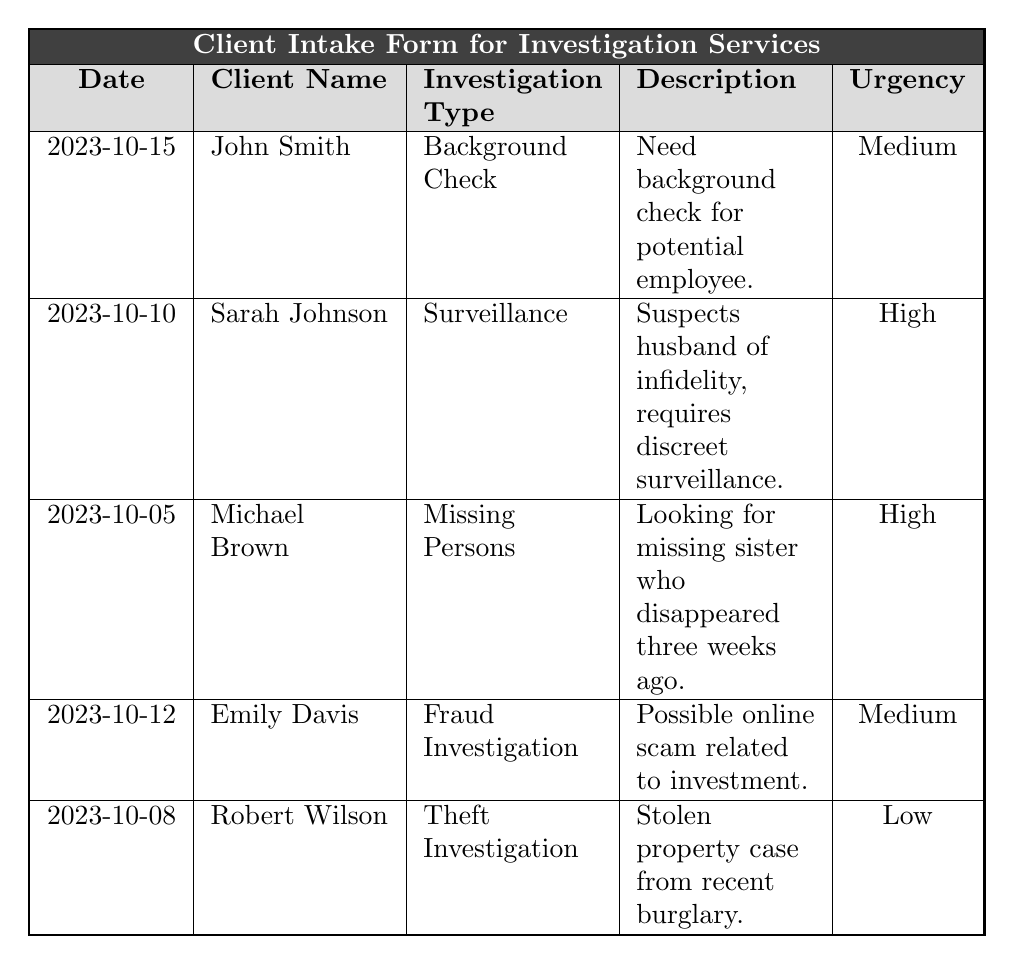What is the most urgent investigation type listed in the table? The table shows different urgency levels for various investigation types. By scanning the urgency column, we see that "High" urgency appears twice, for "Surveillance" and "Missing Persons". Therefore, there is no single most urgent type; both have a high urgency level.
Answer: Surveillance and Missing Persons How many clients have a background check requested? The table lists various clients and their investigation types. Only one client, John Smith, has requested a "Background Check". Thus, we count one instance.
Answer: 1 Which client lives in Colorado? To find the client residing in Colorado, we look at the addresses in the table. Emily Davis lives at "234 Maple Lane, Denver, CO", which indicates she is in Colorado.
Answer: Emily Davis Is there any client requesting an investigation with "Low" urgency? Scanning the urgency level in the table, we find that Robert Wilson has a "Low" urgency level for his theft investigation. Therefore, the answer is affirmative.
Answer: Yes What type of investigation has the least urgency level, and which client requested it? The table shows various urgency levels for different investigation types. The lowest level listed is "Low", which is assigned to Robert Wilson for the "Theft Investigation". Hence, we determine both the urgency level and the associated client.
Answer: Theft Investigation, Robert Wilson What is the date of intake for the client with the highest urgency? To answer this, we first identify all clients with a high urgency, which are Sarah Johnson and Michael Brown. Their dates of intake are October 10 and October 5, respectively. The later date is for Sarah Johnson, who has a high urgency investigation, thus providing us the intake date.
Answer: 2023-10-10 How many clients mentioned a problem related to personal difficulties? Personal difficulties are implied in cases such as "Suspects husband of infidelity" (Sarah Johnson) and "Looking for missing sister" (Michael Brown), which are personal issues. Counting these, we find two clients facing personal difficulties.
Answer: 2 Which client provided an email address that includes "example.com"? By reviewing the email addresses of all clients in the table, we notice that both John Smith and Michael Brown’s email addresses include "example.com". Thus, we count these two clients.
Answer: 2 What is the average urgency level of the investigations listed? The urgency levels are categorized as Low (1), Medium (2), and High (3). The counts are: Low - 1, Medium - 2, High - 2. This gives us a total score of (1*1) + (2*2) + (3*2) = 1 + 4 + 6 = 11. There are 5 clients, so we calculate the average as 11/5 = 2.2. To represent this, we can round it, indicating a slightly above Medium level.
Answer: Approximately Medium Which client is associated with fraud-related concerns? Scanning through the descriptions in the table, we find Emily Davis associated with a "Fraud Investigation" regarding a possible online scam related to investment, directly answering the inquiry.
Answer: Emily Davis 